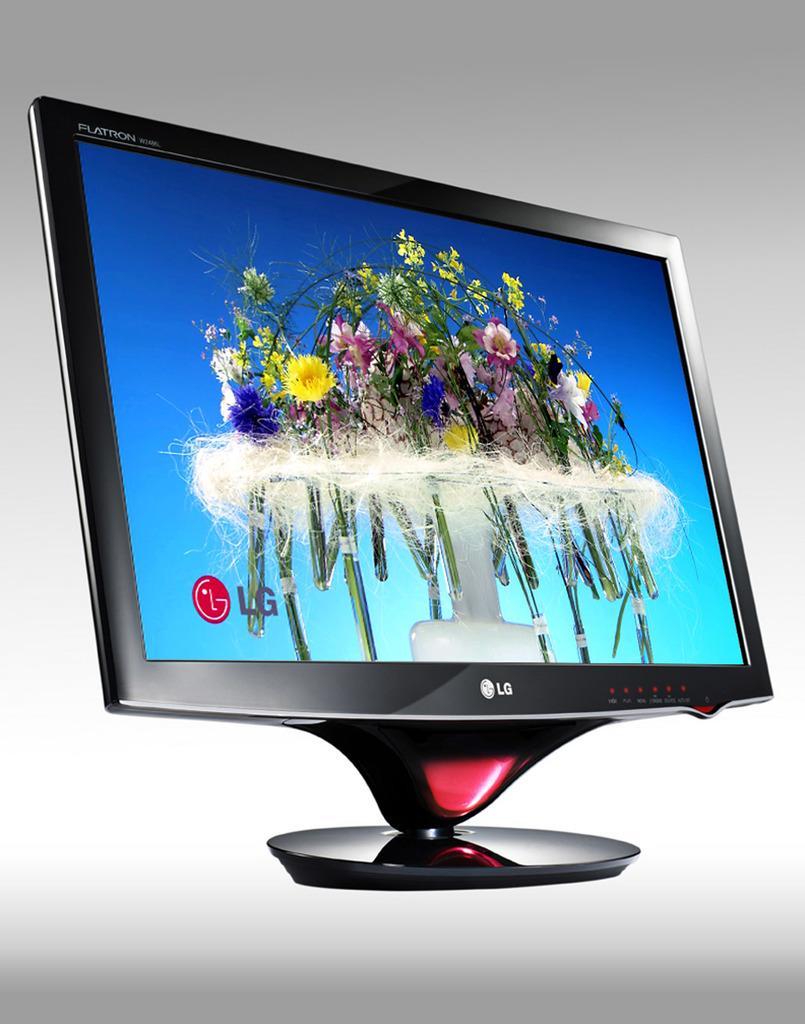Please provide a concise description of this image. In this picture there is a television. In the screen we can see the flowers and water. At the bottom of the screen we can see the company logo. 